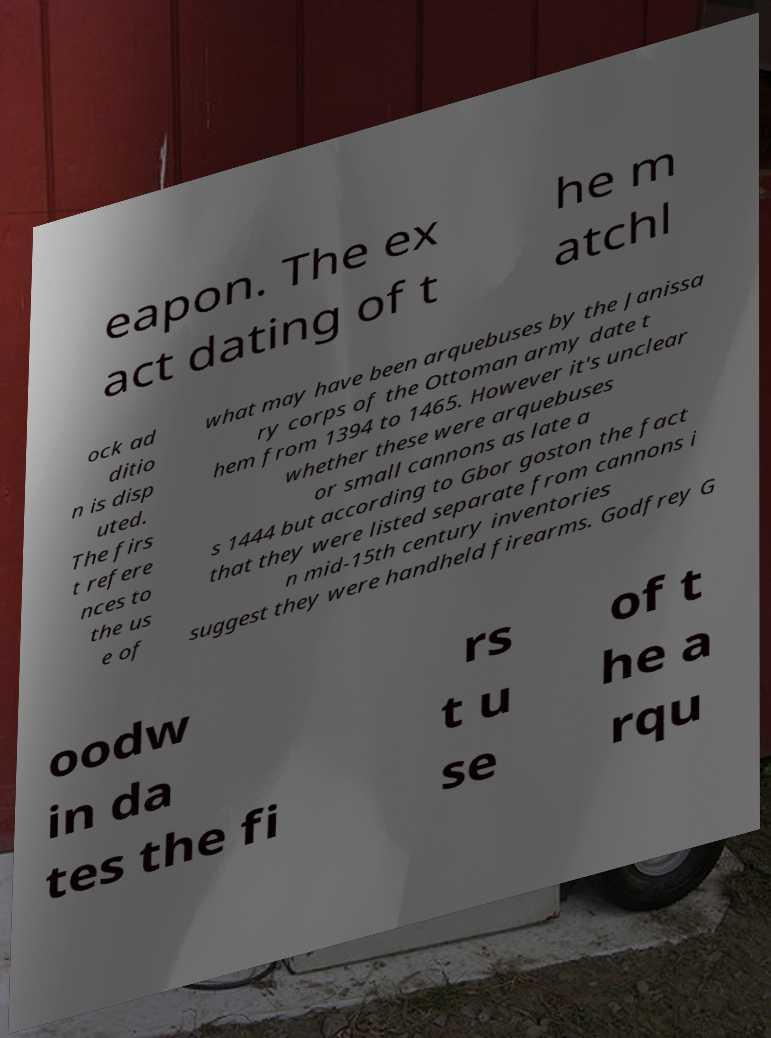Could you assist in decoding the text presented in this image and type it out clearly? eapon. The ex act dating of t he m atchl ock ad ditio n is disp uted. The firs t refere nces to the us e of what may have been arquebuses by the Janissa ry corps of the Ottoman army date t hem from 1394 to 1465. However it's unclear whether these were arquebuses or small cannons as late a s 1444 but according to Gbor goston the fact that they were listed separate from cannons i n mid-15th century inventories suggest they were handheld firearms. Godfrey G oodw in da tes the fi rs t u se of t he a rqu 